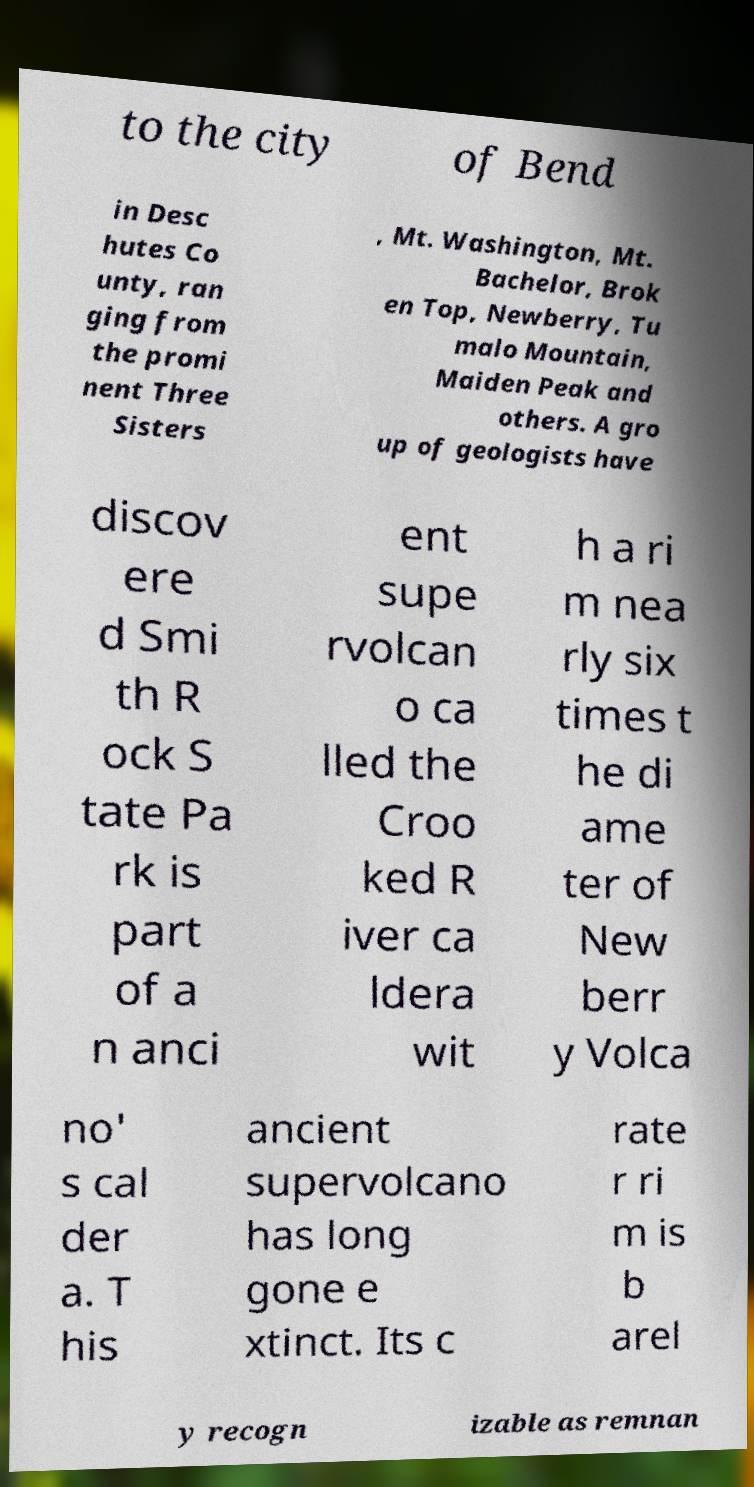Can you accurately transcribe the text from the provided image for me? to the city of Bend in Desc hutes Co unty, ran ging from the promi nent Three Sisters , Mt. Washington, Mt. Bachelor, Brok en Top, Newberry, Tu malo Mountain, Maiden Peak and others. A gro up of geologists have discov ere d Smi th R ock S tate Pa rk is part of a n anci ent supe rvolcan o ca lled the Croo ked R iver ca ldera wit h a ri m nea rly six times t he di ame ter of New berr y Volca no' s cal der a. T his ancient supervolcano has long gone e xtinct. Its c rate r ri m is b arel y recogn izable as remnan 